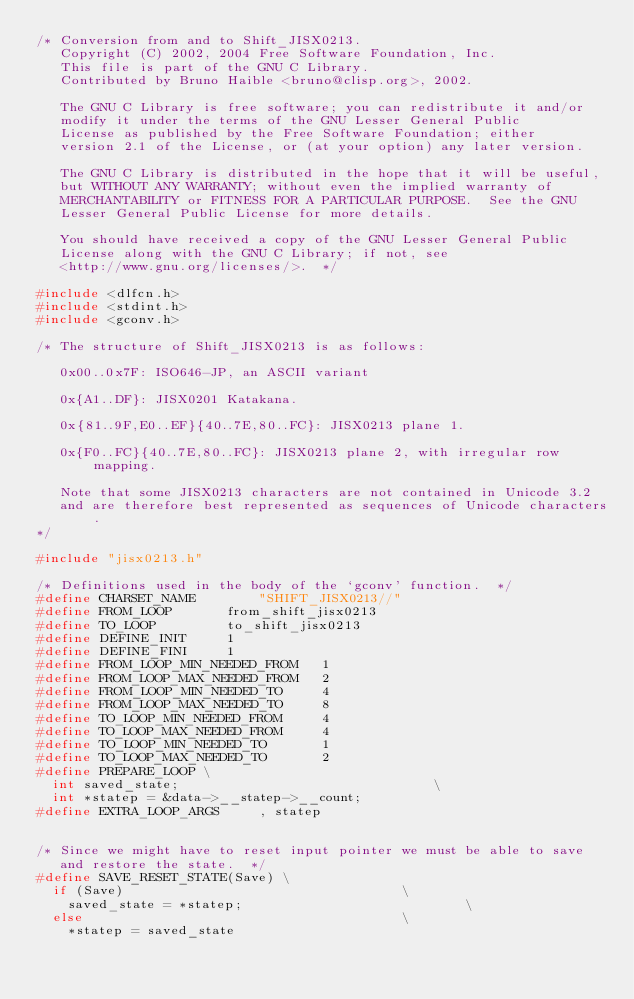<code> <loc_0><loc_0><loc_500><loc_500><_C_>/* Conversion from and to Shift_JISX0213.
   Copyright (C) 2002, 2004 Free Software Foundation, Inc.
   This file is part of the GNU C Library.
   Contributed by Bruno Haible <bruno@clisp.org>, 2002.

   The GNU C Library is free software; you can redistribute it and/or
   modify it under the terms of the GNU Lesser General Public
   License as published by the Free Software Foundation; either
   version 2.1 of the License, or (at your option) any later version.

   The GNU C Library is distributed in the hope that it will be useful,
   but WITHOUT ANY WARRANTY; without even the implied warranty of
   MERCHANTABILITY or FITNESS FOR A PARTICULAR PURPOSE.  See the GNU
   Lesser General Public License for more details.

   You should have received a copy of the GNU Lesser General Public
   License along with the GNU C Library; if not, see
   <http://www.gnu.org/licenses/>.  */

#include <dlfcn.h>
#include <stdint.h>
#include <gconv.h>

/* The structure of Shift_JISX0213 is as follows:

   0x00..0x7F: ISO646-JP, an ASCII variant

   0x{A1..DF}: JISX0201 Katakana.

   0x{81..9F,E0..EF}{40..7E,80..FC}: JISX0213 plane 1.

   0x{F0..FC}{40..7E,80..FC}: JISX0213 plane 2, with irregular row mapping.

   Note that some JISX0213 characters are not contained in Unicode 3.2
   and are therefore best represented as sequences of Unicode characters.
*/

#include "jisx0213.h"

/* Definitions used in the body of the `gconv' function.  */
#define CHARSET_NAME		"SHIFT_JISX0213//"
#define FROM_LOOP		from_shift_jisx0213
#define TO_LOOP			to_shift_jisx0213
#define DEFINE_INIT		1
#define DEFINE_FINI		1
#define FROM_LOOP_MIN_NEEDED_FROM	1
#define FROM_LOOP_MAX_NEEDED_FROM	2
#define FROM_LOOP_MIN_NEEDED_TO		4
#define FROM_LOOP_MAX_NEEDED_TO		8
#define TO_LOOP_MIN_NEEDED_FROM		4
#define TO_LOOP_MAX_NEEDED_FROM		4
#define TO_LOOP_MIN_NEEDED_TO		1
#define TO_LOOP_MAX_NEEDED_TO		2
#define PREPARE_LOOP \
  int saved_state;							      \
  int *statep = &data->__statep->__count;
#define EXTRA_LOOP_ARGS		, statep


/* Since we might have to reset input pointer we must be able to save
   and restore the state.  */
#define SAVE_RESET_STATE(Save) \
  if (Save)								      \
    saved_state = *statep;						      \
  else									      \
    *statep = saved_state

</code> 